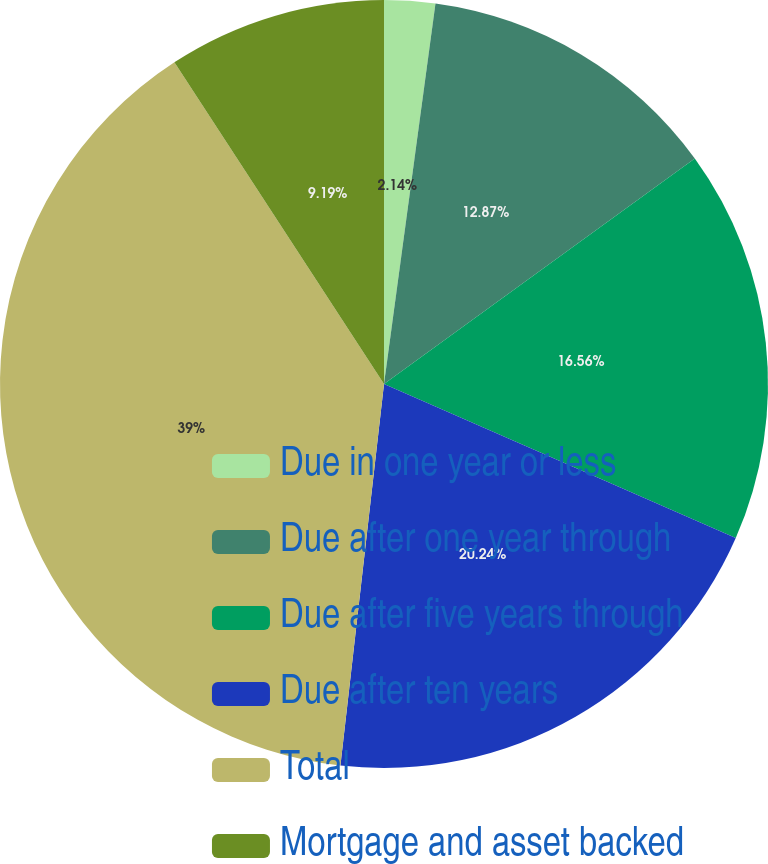Convert chart to OTSL. <chart><loc_0><loc_0><loc_500><loc_500><pie_chart><fcel>Due in one year or less<fcel>Due after one year through<fcel>Due after five years through<fcel>Due after ten years<fcel>Total<fcel>Mortgage and asset backed<nl><fcel>2.14%<fcel>12.87%<fcel>16.56%<fcel>20.24%<fcel>39.0%<fcel>9.19%<nl></chart> 